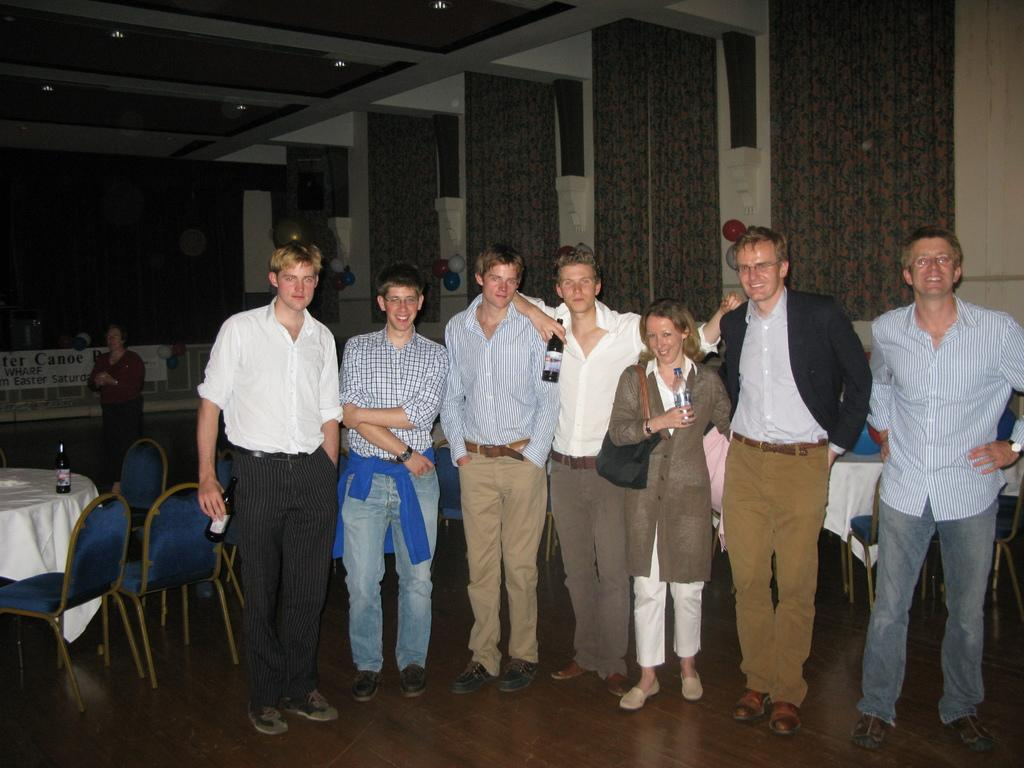What are the people in the image doing? There are people standing in the image, but their specific actions are not clear. What objects are the people holding in their hands? Some people are holding bottles in their hands. What type of furniture is visible in the image? There are chairs visible in the image. What piece of furniture is present in the image that is typically used for placing objects? There is a table in the image. What objects are on the table in the image? There are bottles on the table. What can be seen in the image that provides illumination? There is a light source in the image. What type of harmony is being played by the people in the image? There is no indication of music or harmony in the image; it only shows people standing and holding bottles. 